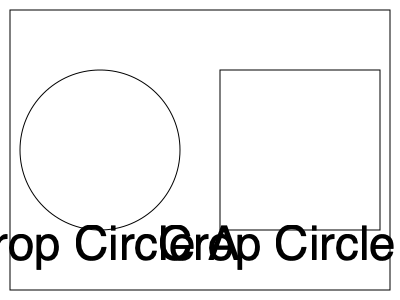Two crop circles have been discovered in a field. Crop Circle A is perfectly circular with a diameter of 160 meters. Crop Circle B is a square with a side length equal to the radius of Crop Circle A. What is the difference in area between Crop Circle A and Crop Circle B in square meters? Round your answer to the nearest whole number. To solve this problem, let's follow these steps:

1. Calculate the radius of Crop Circle A:
   Diameter = 160 meters
   Radius = Diameter ÷ 2 = 160 ÷ 2 = 80 meters

2. Calculate the area of Crop Circle A:
   Area of a circle = $\pi r^2$
   Area A = $\pi \times 80^2 = 6400\pi$ square meters

3. Calculate the side length of Crop Circle B:
   Side length = Radius of Crop Circle A = 80 meters

4. Calculate the area of Crop Circle B:
   Area of a square = side length squared
   Area B = $80^2 = 6400$ square meters

5. Calculate the difference in area:
   Difference = Area A - Area B
   Difference = $6400\pi - 6400$ square meters

6. Evaluate and round to the nearest whole number:
   $6400\pi - 6400 \approx 20,106.19 - 6400 \approx 13,706.19$

   Rounded to the nearest whole number: 13,706 square meters
Answer: 13,706 square meters 